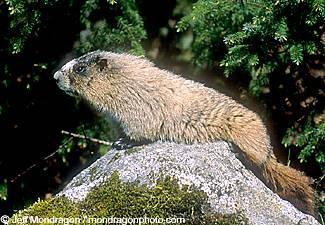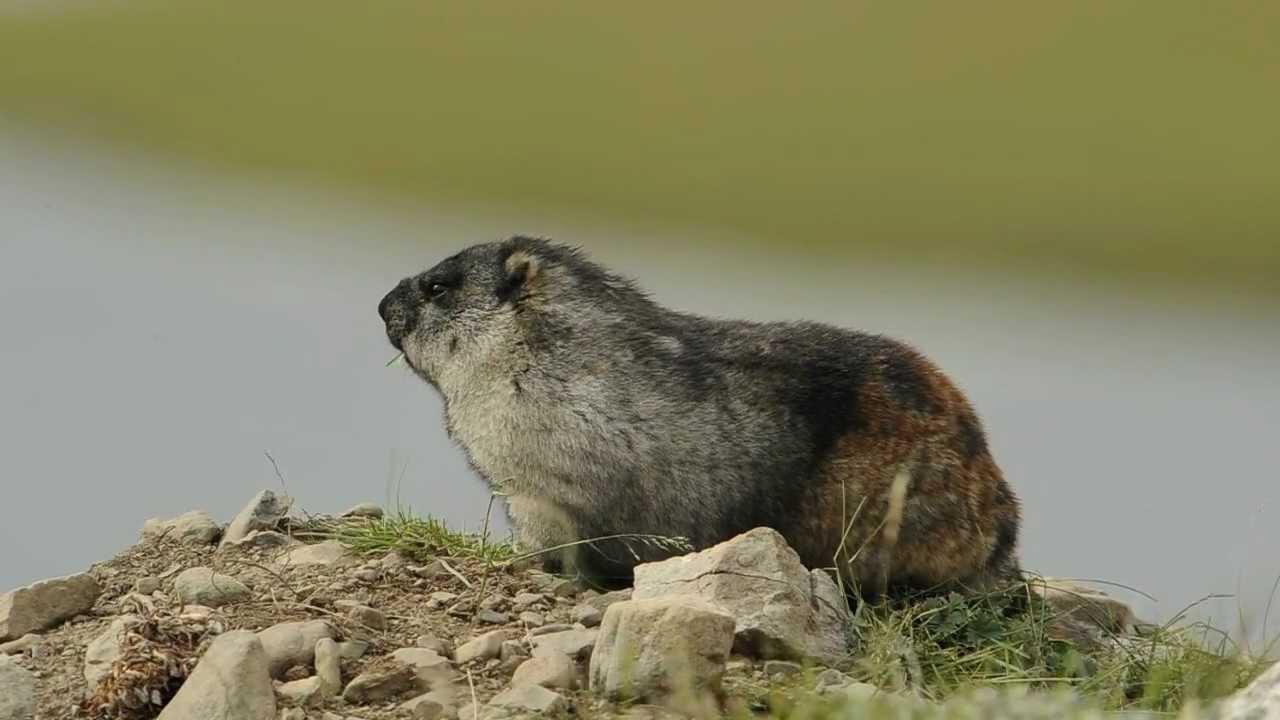The first image is the image on the left, the second image is the image on the right. For the images shown, is this caption "The animals in the image on the left are on a rocky peak." true? Answer yes or no. Yes. The first image is the image on the left, the second image is the image on the right. Given the left and right images, does the statement "The marmot in the left image is looking in the direction of the camera" hold true? Answer yes or no. No. 